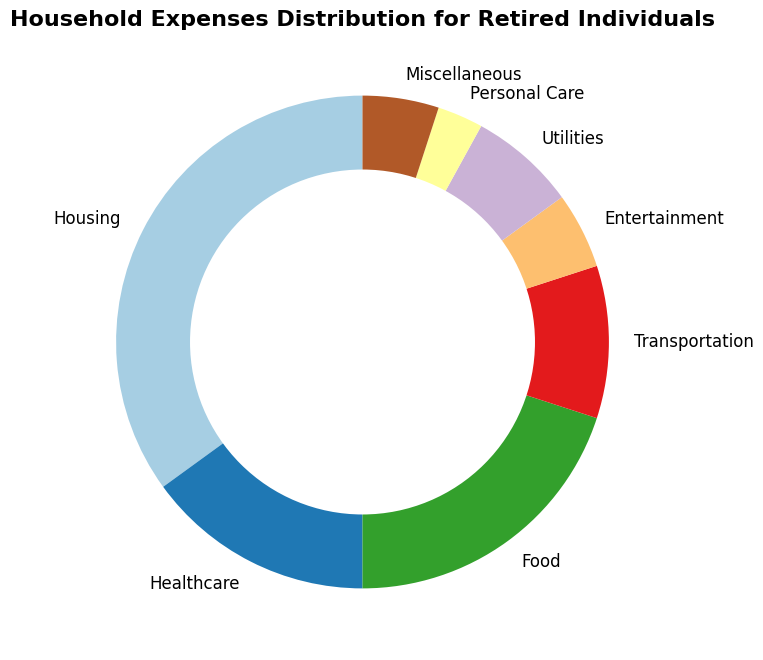What percentage of the total expenses is spent on food and healthcare combined? First, identify the percentages for food and healthcare from the chart, which are 20% and 15%, respectively. Then, add these percentages together: 20% + 15% = 35%.
Answer: 35% Which category has the highest percentage of household expenses? Review the chart and find the category with the largest portion. Housing stands out as the largest segment and is labeled with a percentage of 35%.
Answer: Housing Is the percentage spent on entertainment greater than or less than the percentage spent on transportation? Locate the entertainment and transportation sections on the chart. Entertainment has a percentage of 5%, while transportation has a percentage of 10%. Clearly, 5% is less than 10%.
Answer: Less than How much more is spent on housing compared to utilities and personal care combined? First, identify the percentages: Housing (35%), Utilities (7%), Personal Care (3%). Then, sum up the percentages for utilities and personal care: 7% + 3% = 10%. Finally, subtract this sum from the housing percentage: 35% - 10% = 25%.
Answer: 25% Which categories together make up the smallest portion of the expenses and what is their combined percentage? Identify the smallest portions in the chart: Personal Care (3%) and Miscellaneous (5%). Adding these together gives: 3% + 5% = 8%.
Answer: Personal Care and Miscellaneous, 8% What is the difference in percentage between the largest and smallest expense categories? The largest category is Housing at 35%, and the smallest is Personal Care at 3%. Subtract the smallest from the largest: 35% - 3% = 32%.
Answer: 32% If healthcare expenses increased by 5%, what would the new percentage be? The current healthcare percentage is 15%. Adding 5% to this gives: 15% + 5% = 20%.
Answer: 20% List the categories that have a percentage of 10% or more. Survey the chart for categories with percentages 10% or higher: Housing (35%), Healthcare (15%), Food (20%), and Transportation (10%).
Answer: Housing, Healthcare, Food, Transportation Which has a higher percentage: utilities or entertainment? By how much? Locate the percentages for utilities and entertainment in the chart: Utilities have 7%, and Entertainment has 5%. Compute the difference: 7% - 5% = 2%.
Answer: Utilities by 2% 